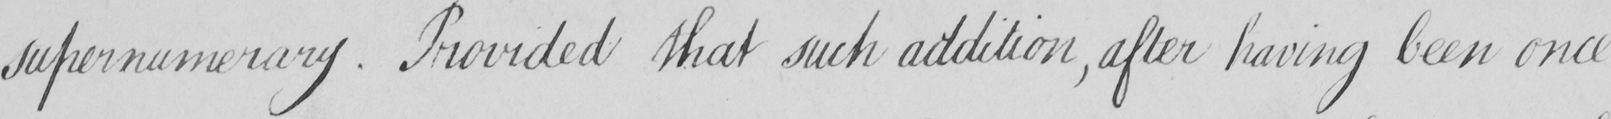Transcribe the text shown in this historical manuscript line. supernumerary . Provided that such addition  , after having been once 